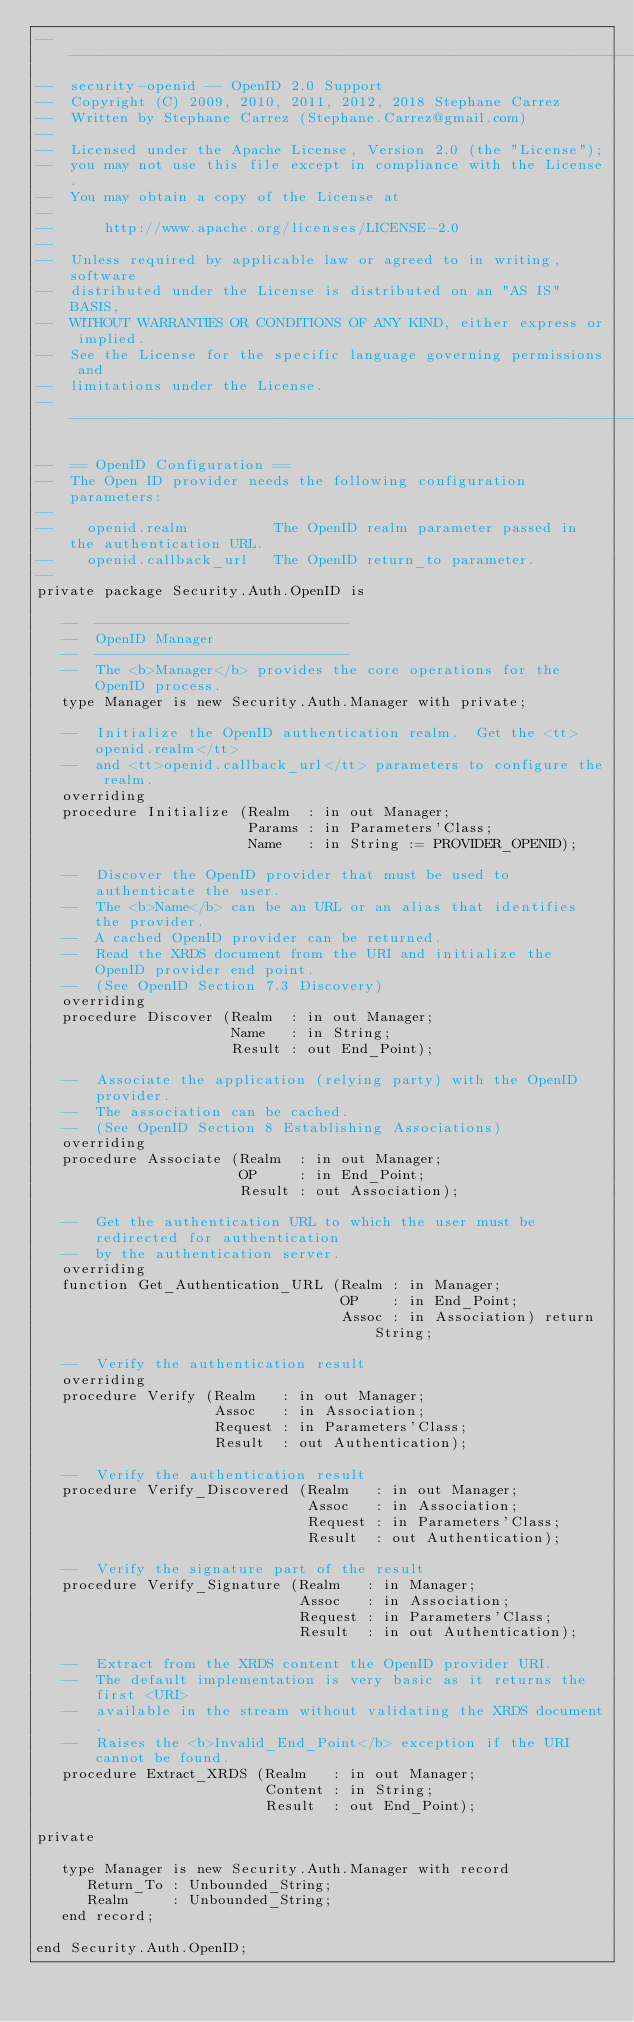Convert code to text. <code><loc_0><loc_0><loc_500><loc_500><_Ada_>-----------------------------------------------------------------------
--  security-openid -- OpenID 2.0 Support
--  Copyright (C) 2009, 2010, 2011, 2012, 2018 Stephane Carrez
--  Written by Stephane Carrez (Stephane.Carrez@gmail.com)
--
--  Licensed under the Apache License, Version 2.0 (the "License");
--  you may not use this file except in compliance with the License.
--  You may obtain a copy of the License at
--
--      http://www.apache.org/licenses/LICENSE-2.0
--
--  Unless required by applicable law or agreed to in writing, software
--  distributed under the License is distributed on an "AS IS" BASIS,
--  WITHOUT WARRANTIES OR CONDITIONS OF ANY KIND, either express or implied.
--  See the License for the specific language governing permissions and
--  limitations under the License.
-----------------------------------------------------------------------

--  == OpenID Configuration ==
--  The Open ID provider needs the following configuration parameters:
--
--    openid.realm          The OpenID realm parameter passed in the authentication URL.
--    openid.callback_url   The OpenID return_to parameter.
--
private package Security.Auth.OpenID is

   --  ------------------------------
   --  OpenID Manager
   --  ------------------------------
   --  The <b>Manager</b> provides the core operations for the OpenID process.
   type Manager is new Security.Auth.Manager with private;

   --  Initialize the OpenID authentication realm.  Get the <tt>openid.realm</tt>
   --  and <tt>openid.callback_url</tt> parameters to configure the realm.
   overriding
   procedure Initialize (Realm  : in out Manager;
                         Params : in Parameters'Class;
                         Name   : in String := PROVIDER_OPENID);

   --  Discover the OpenID provider that must be used to authenticate the user.
   --  The <b>Name</b> can be an URL or an alias that identifies the provider.
   --  A cached OpenID provider can be returned.
   --  Read the XRDS document from the URI and initialize the OpenID provider end point.
   --  (See OpenID Section 7.3 Discovery)
   overriding
   procedure Discover (Realm  : in out Manager;
                       Name   : in String;
                       Result : out End_Point);

   --  Associate the application (relying party) with the OpenID provider.
   --  The association can be cached.
   --  (See OpenID Section 8 Establishing Associations)
   overriding
   procedure Associate (Realm  : in out Manager;
                        OP     : in End_Point;
                        Result : out Association);

   --  Get the authentication URL to which the user must be redirected for authentication
   --  by the authentication server.
   overriding
   function Get_Authentication_URL (Realm : in Manager;
                                    OP    : in End_Point;
                                    Assoc : in Association) return String;

   --  Verify the authentication result
   overriding
   procedure Verify (Realm   : in out Manager;
                     Assoc   : in Association;
                     Request : in Parameters'Class;
                     Result  : out Authentication);

   --  Verify the authentication result
   procedure Verify_Discovered (Realm   : in out Manager;
                                Assoc   : in Association;
                                Request : in Parameters'Class;
                                Result  : out Authentication);

   --  Verify the signature part of the result
   procedure Verify_Signature (Realm   : in Manager;
                               Assoc   : in Association;
                               Request : in Parameters'Class;
                               Result  : in out Authentication);

   --  Extract from the XRDS content the OpenID provider URI.
   --  The default implementation is very basic as it returns the first <URI>
   --  available in the stream without validating the XRDS document.
   --  Raises the <b>Invalid_End_Point</b> exception if the URI cannot be found.
   procedure Extract_XRDS (Realm   : in out Manager;
                           Content : in String;
                           Result  : out End_Point);

private

   type Manager is new Security.Auth.Manager with record
      Return_To : Unbounded_String;
      Realm     : Unbounded_String;
   end record;

end Security.Auth.OpenID;
</code> 